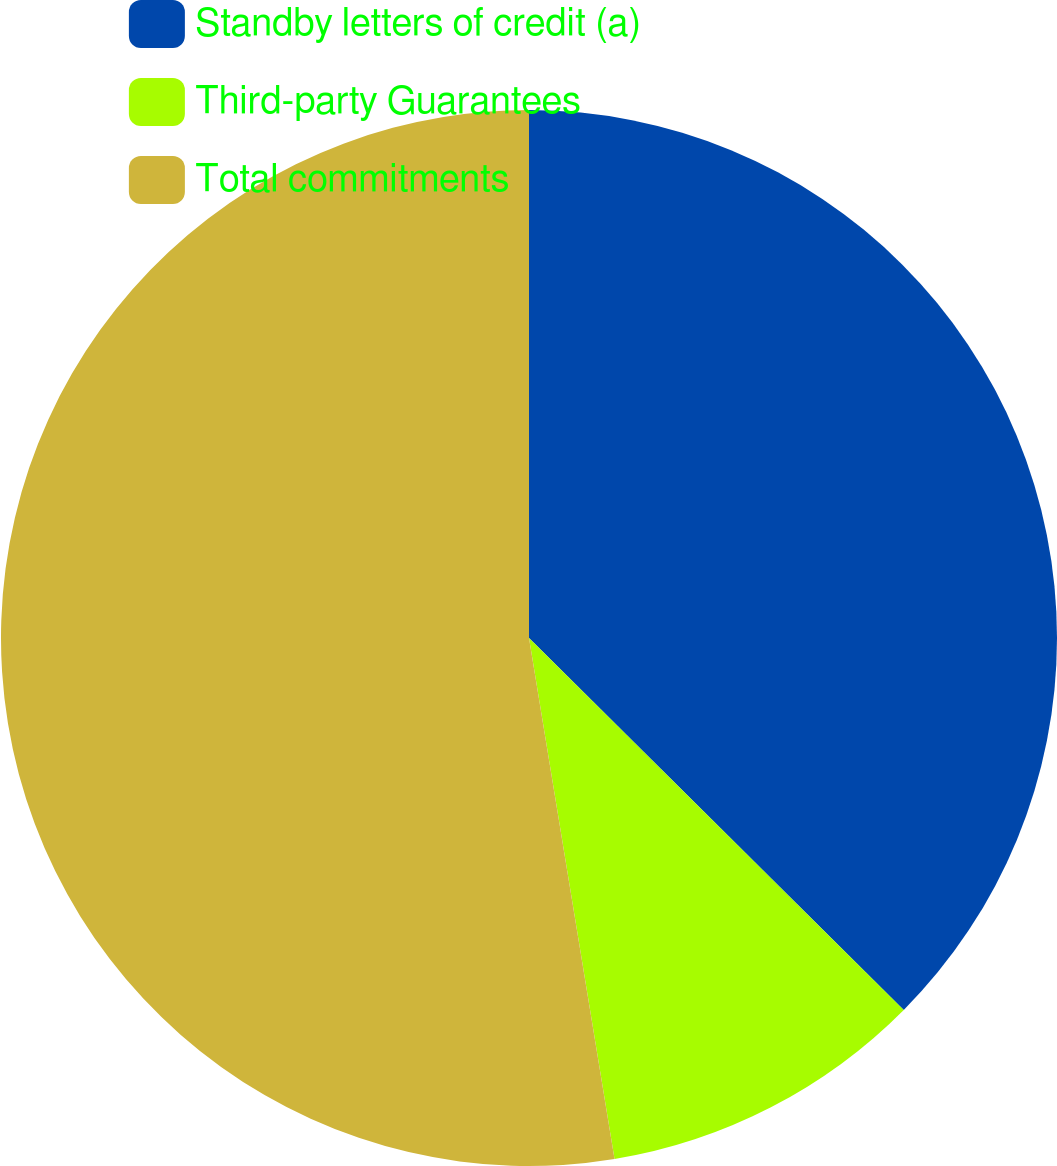<chart> <loc_0><loc_0><loc_500><loc_500><pie_chart><fcel>Standby letters of credit (a)<fcel>Third-party Guarantees<fcel>Total commitments<nl><fcel>37.44%<fcel>9.97%<fcel>52.59%<nl></chart> 